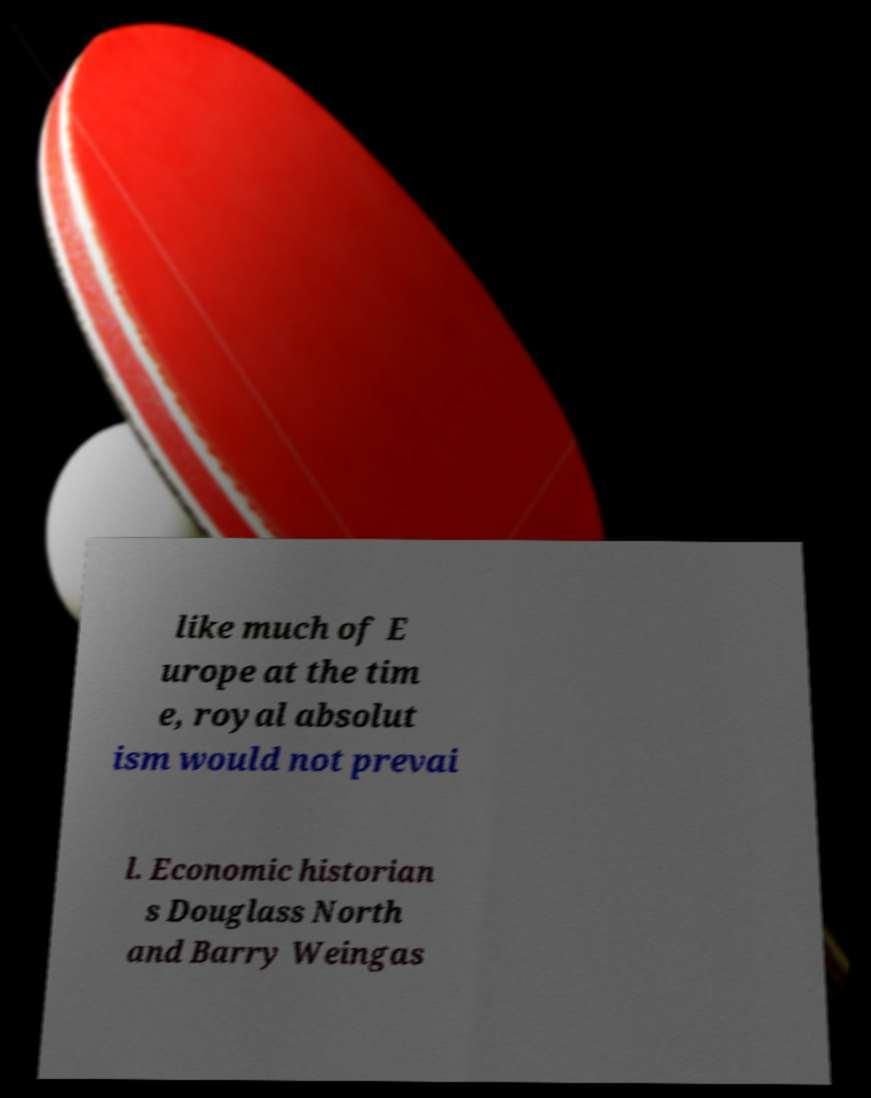Please identify and transcribe the text found in this image. like much of E urope at the tim e, royal absolut ism would not prevai l. Economic historian s Douglass North and Barry Weingas 